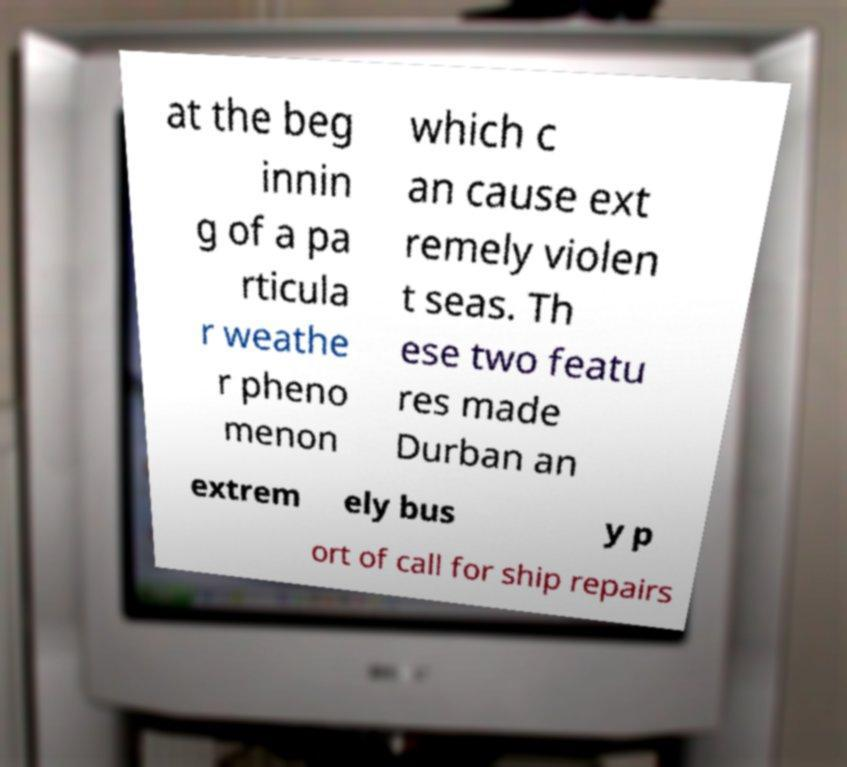Please read and relay the text visible in this image. What does it say? at the beg innin g of a pa rticula r weathe r pheno menon which c an cause ext remely violen t seas. Th ese two featu res made Durban an extrem ely bus y p ort of call for ship repairs 